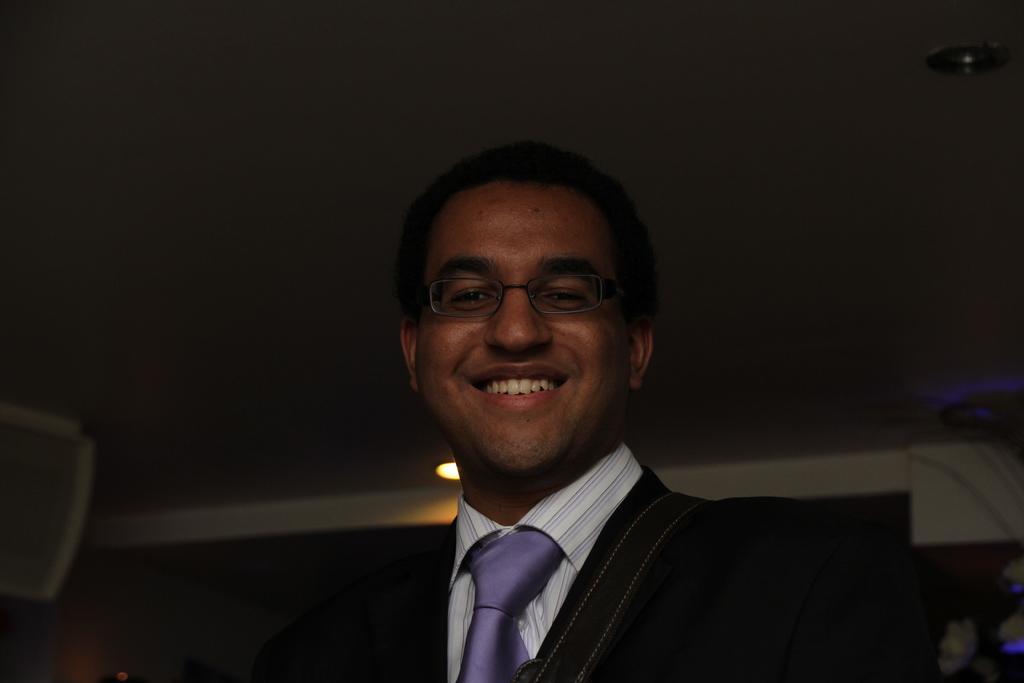Could you give a brief overview of what you see in this image? In this image I can see a person and the person is wearing black blazer, white shirt and purple color tie. Background I can see a light. 